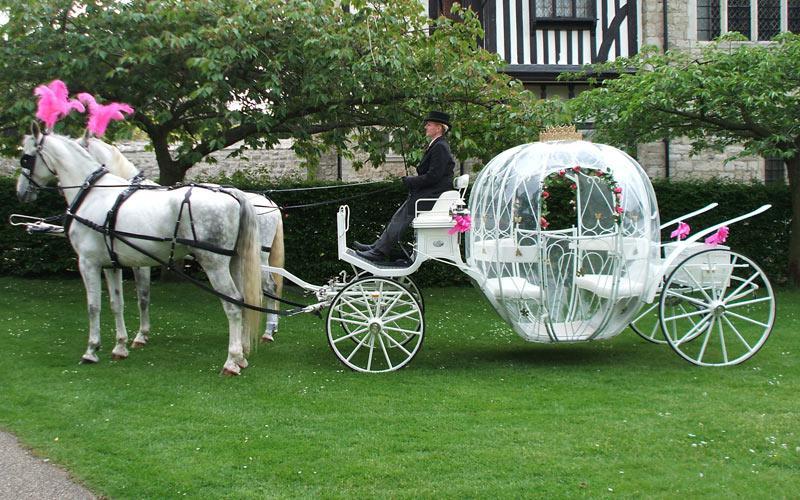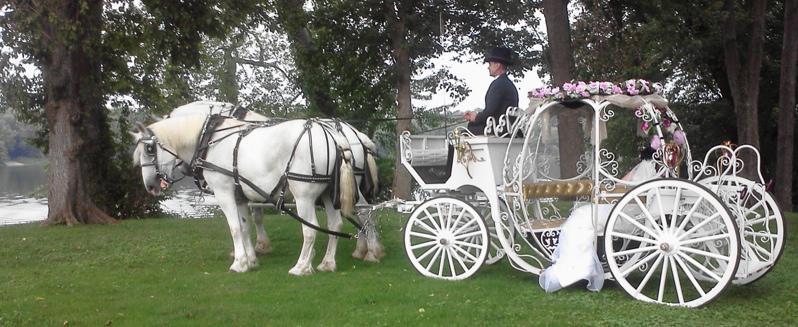The first image is the image on the left, the second image is the image on the right. Given the left and right images, does the statement "The left image shows a carriage pulled by a brown horse." hold true? Answer yes or no. No. 